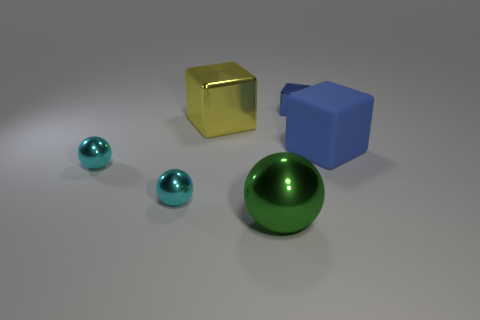Subtract all big green shiny spheres. How many spheres are left? 2 Subtract all purple balls. How many blue blocks are left? 2 Subtract all cyan spheres. How many spheres are left? 1 Subtract 1 cubes. How many cubes are left? 2 Add 3 small metallic objects. How many objects exist? 9 Subtract all matte things. Subtract all cubes. How many objects are left? 2 Add 4 big things. How many big things are left? 7 Add 5 big green things. How many big green things exist? 6 Subtract 0 red cylinders. How many objects are left? 6 Subtract all green spheres. Subtract all yellow cylinders. How many spheres are left? 2 